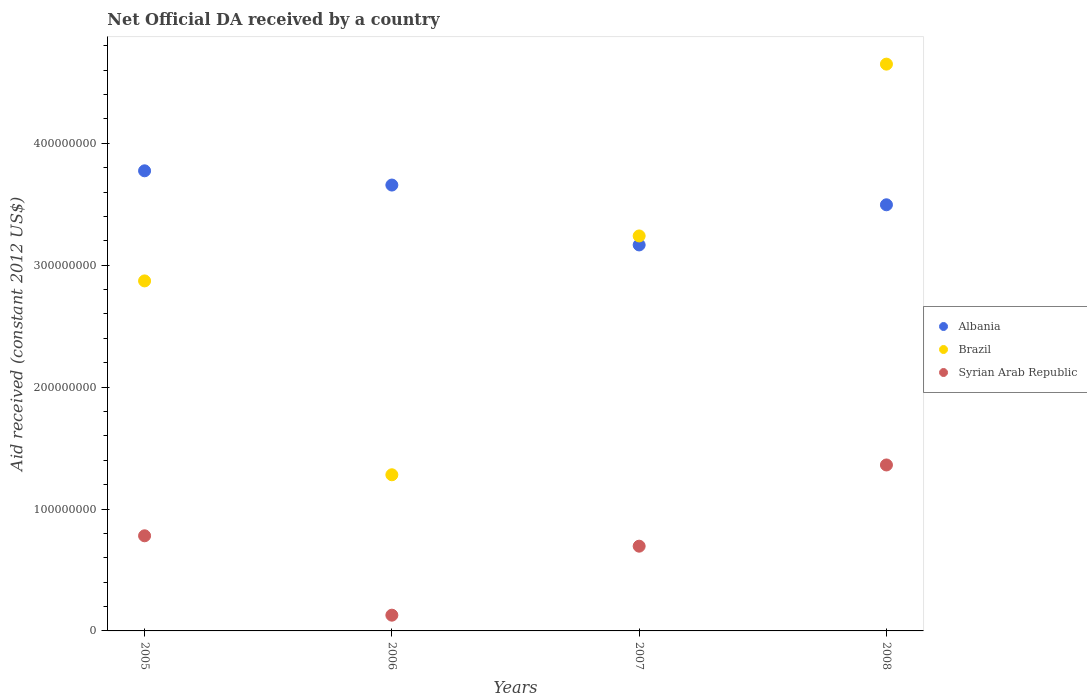How many different coloured dotlines are there?
Offer a very short reply. 3. Is the number of dotlines equal to the number of legend labels?
Make the answer very short. Yes. What is the net official development assistance aid received in Syrian Arab Republic in 2007?
Your response must be concise. 6.95e+07. Across all years, what is the maximum net official development assistance aid received in Syrian Arab Republic?
Keep it short and to the point. 1.36e+08. Across all years, what is the minimum net official development assistance aid received in Syrian Arab Republic?
Provide a short and direct response. 1.29e+07. In which year was the net official development assistance aid received in Syrian Arab Republic minimum?
Make the answer very short. 2006. What is the total net official development assistance aid received in Albania in the graph?
Provide a succinct answer. 1.41e+09. What is the difference between the net official development assistance aid received in Albania in 2005 and that in 2007?
Make the answer very short. 6.08e+07. What is the difference between the net official development assistance aid received in Syrian Arab Republic in 2006 and the net official development assistance aid received in Albania in 2007?
Keep it short and to the point. -3.04e+08. What is the average net official development assistance aid received in Brazil per year?
Provide a succinct answer. 3.01e+08. In the year 2005, what is the difference between the net official development assistance aid received in Albania and net official development assistance aid received in Syrian Arab Republic?
Provide a succinct answer. 2.99e+08. In how many years, is the net official development assistance aid received in Brazil greater than 420000000 US$?
Give a very brief answer. 1. What is the ratio of the net official development assistance aid received in Syrian Arab Republic in 2006 to that in 2008?
Keep it short and to the point. 0.09. Is the net official development assistance aid received in Brazil in 2005 less than that in 2007?
Your answer should be very brief. Yes. What is the difference between the highest and the second highest net official development assistance aid received in Brazil?
Offer a very short reply. 1.41e+08. What is the difference between the highest and the lowest net official development assistance aid received in Albania?
Offer a terse response. 6.08e+07. Is the sum of the net official development assistance aid received in Syrian Arab Republic in 2007 and 2008 greater than the maximum net official development assistance aid received in Brazil across all years?
Give a very brief answer. No. Is the net official development assistance aid received in Brazil strictly greater than the net official development assistance aid received in Albania over the years?
Ensure brevity in your answer.  No. Is the net official development assistance aid received in Albania strictly less than the net official development assistance aid received in Syrian Arab Republic over the years?
Keep it short and to the point. No. How many years are there in the graph?
Make the answer very short. 4. Where does the legend appear in the graph?
Provide a succinct answer. Center right. How many legend labels are there?
Your answer should be very brief. 3. How are the legend labels stacked?
Make the answer very short. Vertical. What is the title of the graph?
Ensure brevity in your answer.  Net Official DA received by a country. What is the label or title of the X-axis?
Keep it short and to the point. Years. What is the label or title of the Y-axis?
Keep it short and to the point. Aid received (constant 2012 US$). What is the Aid received (constant 2012 US$) of Albania in 2005?
Keep it short and to the point. 3.77e+08. What is the Aid received (constant 2012 US$) of Brazil in 2005?
Provide a succinct answer. 2.87e+08. What is the Aid received (constant 2012 US$) in Syrian Arab Republic in 2005?
Keep it short and to the point. 7.80e+07. What is the Aid received (constant 2012 US$) in Albania in 2006?
Your response must be concise. 3.66e+08. What is the Aid received (constant 2012 US$) of Brazil in 2006?
Offer a terse response. 1.28e+08. What is the Aid received (constant 2012 US$) in Syrian Arab Republic in 2006?
Your answer should be compact. 1.29e+07. What is the Aid received (constant 2012 US$) in Albania in 2007?
Provide a succinct answer. 3.17e+08. What is the Aid received (constant 2012 US$) of Brazil in 2007?
Offer a very short reply. 3.24e+08. What is the Aid received (constant 2012 US$) of Syrian Arab Republic in 2007?
Your response must be concise. 6.95e+07. What is the Aid received (constant 2012 US$) in Albania in 2008?
Your response must be concise. 3.50e+08. What is the Aid received (constant 2012 US$) of Brazil in 2008?
Offer a very short reply. 4.65e+08. What is the Aid received (constant 2012 US$) of Syrian Arab Republic in 2008?
Ensure brevity in your answer.  1.36e+08. Across all years, what is the maximum Aid received (constant 2012 US$) in Albania?
Your answer should be very brief. 3.77e+08. Across all years, what is the maximum Aid received (constant 2012 US$) of Brazil?
Your response must be concise. 4.65e+08. Across all years, what is the maximum Aid received (constant 2012 US$) of Syrian Arab Republic?
Provide a succinct answer. 1.36e+08. Across all years, what is the minimum Aid received (constant 2012 US$) of Albania?
Provide a short and direct response. 3.17e+08. Across all years, what is the minimum Aid received (constant 2012 US$) of Brazil?
Make the answer very short. 1.28e+08. Across all years, what is the minimum Aid received (constant 2012 US$) in Syrian Arab Republic?
Your answer should be very brief. 1.29e+07. What is the total Aid received (constant 2012 US$) in Albania in the graph?
Provide a short and direct response. 1.41e+09. What is the total Aid received (constant 2012 US$) in Brazil in the graph?
Provide a short and direct response. 1.20e+09. What is the total Aid received (constant 2012 US$) in Syrian Arab Republic in the graph?
Ensure brevity in your answer.  2.97e+08. What is the difference between the Aid received (constant 2012 US$) in Albania in 2005 and that in 2006?
Offer a terse response. 1.17e+07. What is the difference between the Aid received (constant 2012 US$) in Brazil in 2005 and that in 2006?
Offer a very short reply. 1.59e+08. What is the difference between the Aid received (constant 2012 US$) of Syrian Arab Republic in 2005 and that in 2006?
Your answer should be very brief. 6.51e+07. What is the difference between the Aid received (constant 2012 US$) in Albania in 2005 and that in 2007?
Make the answer very short. 6.08e+07. What is the difference between the Aid received (constant 2012 US$) of Brazil in 2005 and that in 2007?
Your answer should be compact. -3.69e+07. What is the difference between the Aid received (constant 2012 US$) in Syrian Arab Republic in 2005 and that in 2007?
Your answer should be very brief. 8.52e+06. What is the difference between the Aid received (constant 2012 US$) of Albania in 2005 and that in 2008?
Make the answer very short. 2.79e+07. What is the difference between the Aid received (constant 2012 US$) in Brazil in 2005 and that in 2008?
Your answer should be very brief. -1.78e+08. What is the difference between the Aid received (constant 2012 US$) of Syrian Arab Republic in 2005 and that in 2008?
Provide a succinct answer. -5.81e+07. What is the difference between the Aid received (constant 2012 US$) in Albania in 2006 and that in 2007?
Your response must be concise. 4.91e+07. What is the difference between the Aid received (constant 2012 US$) in Brazil in 2006 and that in 2007?
Give a very brief answer. -1.96e+08. What is the difference between the Aid received (constant 2012 US$) in Syrian Arab Republic in 2006 and that in 2007?
Your answer should be very brief. -5.66e+07. What is the difference between the Aid received (constant 2012 US$) in Albania in 2006 and that in 2008?
Give a very brief answer. 1.62e+07. What is the difference between the Aid received (constant 2012 US$) of Brazil in 2006 and that in 2008?
Provide a succinct answer. -3.37e+08. What is the difference between the Aid received (constant 2012 US$) of Syrian Arab Republic in 2006 and that in 2008?
Your answer should be compact. -1.23e+08. What is the difference between the Aid received (constant 2012 US$) of Albania in 2007 and that in 2008?
Provide a short and direct response. -3.29e+07. What is the difference between the Aid received (constant 2012 US$) in Brazil in 2007 and that in 2008?
Make the answer very short. -1.41e+08. What is the difference between the Aid received (constant 2012 US$) of Syrian Arab Republic in 2007 and that in 2008?
Keep it short and to the point. -6.66e+07. What is the difference between the Aid received (constant 2012 US$) in Albania in 2005 and the Aid received (constant 2012 US$) in Brazil in 2006?
Provide a succinct answer. 2.49e+08. What is the difference between the Aid received (constant 2012 US$) in Albania in 2005 and the Aid received (constant 2012 US$) in Syrian Arab Republic in 2006?
Keep it short and to the point. 3.65e+08. What is the difference between the Aid received (constant 2012 US$) in Brazil in 2005 and the Aid received (constant 2012 US$) in Syrian Arab Republic in 2006?
Your response must be concise. 2.74e+08. What is the difference between the Aid received (constant 2012 US$) of Albania in 2005 and the Aid received (constant 2012 US$) of Brazil in 2007?
Make the answer very short. 5.34e+07. What is the difference between the Aid received (constant 2012 US$) of Albania in 2005 and the Aid received (constant 2012 US$) of Syrian Arab Republic in 2007?
Your response must be concise. 3.08e+08. What is the difference between the Aid received (constant 2012 US$) of Brazil in 2005 and the Aid received (constant 2012 US$) of Syrian Arab Republic in 2007?
Give a very brief answer. 2.18e+08. What is the difference between the Aid received (constant 2012 US$) in Albania in 2005 and the Aid received (constant 2012 US$) in Brazil in 2008?
Give a very brief answer. -8.75e+07. What is the difference between the Aid received (constant 2012 US$) in Albania in 2005 and the Aid received (constant 2012 US$) in Syrian Arab Republic in 2008?
Offer a very short reply. 2.41e+08. What is the difference between the Aid received (constant 2012 US$) in Brazil in 2005 and the Aid received (constant 2012 US$) in Syrian Arab Republic in 2008?
Give a very brief answer. 1.51e+08. What is the difference between the Aid received (constant 2012 US$) of Albania in 2006 and the Aid received (constant 2012 US$) of Brazil in 2007?
Provide a succinct answer. 4.18e+07. What is the difference between the Aid received (constant 2012 US$) in Albania in 2006 and the Aid received (constant 2012 US$) in Syrian Arab Republic in 2007?
Keep it short and to the point. 2.96e+08. What is the difference between the Aid received (constant 2012 US$) of Brazil in 2006 and the Aid received (constant 2012 US$) of Syrian Arab Republic in 2007?
Provide a succinct answer. 5.86e+07. What is the difference between the Aid received (constant 2012 US$) of Albania in 2006 and the Aid received (constant 2012 US$) of Brazil in 2008?
Offer a very short reply. -9.92e+07. What is the difference between the Aid received (constant 2012 US$) of Albania in 2006 and the Aid received (constant 2012 US$) of Syrian Arab Republic in 2008?
Your answer should be compact. 2.30e+08. What is the difference between the Aid received (constant 2012 US$) of Brazil in 2006 and the Aid received (constant 2012 US$) of Syrian Arab Republic in 2008?
Offer a terse response. -8.05e+06. What is the difference between the Aid received (constant 2012 US$) in Albania in 2007 and the Aid received (constant 2012 US$) in Brazil in 2008?
Provide a succinct answer. -1.48e+08. What is the difference between the Aid received (constant 2012 US$) of Albania in 2007 and the Aid received (constant 2012 US$) of Syrian Arab Republic in 2008?
Your answer should be very brief. 1.80e+08. What is the difference between the Aid received (constant 2012 US$) in Brazil in 2007 and the Aid received (constant 2012 US$) in Syrian Arab Republic in 2008?
Ensure brevity in your answer.  1.88e+08. What is the average Aid received (constant 2012 US$) of Albania per year?
Your answer should be compact. 3.52e+08. What is the average Aid received (constant 2012 US$) in Brazil per year?
Keep it short and to the point. 3.01e+08. What is the average Aid received (constant 2012 US$) in Syrian Arab Republic per year?
Keep it short and to the point. 7.42e+07. In the year 2005, what is the difference between the Aid received (constant 2012 US$) in Albania and Aid received (constant 2012 US$) in Brazil?
Provide a short and direct response. 9.03e+07. In the year 2005, what is the difference between the Aid received (constant 2012 US$) in Albania and Aid received (constant 2012 US$) in Syrian Arab Republic?
Provide a short and direct response. 2.99e+08. In the year 2005, what is the difference between the Aid received (constant 2012 US$) in Brazil and Aid received (constant 2012 US$) in Syrian Arab Republic?
Your answer should be very brief. 2.09e+08. In the year 2006, what is the difference between the Aid received (constant 2012 US$) of Albania and Aid received (constant 2012 US$) of Brazil?
Offer a very short reply. 2.38e+08. In the year 2006, what is the difference between the Aid received (constant 2012 US$) in Albania and Aid received (constant 2012 US$) in Syrian Arab Republic?
Your response must be concise. 3.53e+08. In the year 2006, what is the difference between the Aid received (constant 2012 US$) in Brazil and Aid received (constant 2012 US$) in Syrian Arab Republic?
Provide a short and direct response. 1.15e+08. In the year 2007, what is the difference between the Aid received (constant 2012 US$) of Albania and Aid received (constant 2012 US$) of Brazil?
Offer a terse response. -7.38e+06. In the year 2007, what is the difference between the Aid received (constant 2012 US$) of Albania and Aid received (constant 2012 US$) of Syrian Arab Republic?
Offer a terse response. 2.47e+08. In the year 2007, what is the difference between the Aid received (constant 2012 US$) of Brazil and Aid received (constant 2012 US$) of Syrian Arab Republic?
Make the answer very short. 2.55e+08. In the year 2008, what is the difference between the Aid received (constant 2012 US$) in Albania and Aid received (constant 2012 US$) in Brazil?
Make the answer very short. -1.15e+08. In the year 2008, what is the difference between the Aid received (constant 2012 US$) of Albania and Aid received (constant 2012 US$) of Syrian Arab Republic?
Give a very brief answer. 2.13e+08. In the year 2008, what is the difference between the Aid received (constant 2012 US$) in Brazil and Aid received (constant 2012 US$) in Syrian Arab Republic?
Your answer should be compact. 3.29e+08. What is the ratio of the Aid received (constant 2012 US$) in Albania in 2005 to that in 2006?
Make the answer very short. 1.03. What is the ratio of the Aid received (constant 2012 US$) of Brazil in 2005 to that in 2006?
Ensure brevity in your answer.  2.24. What is the ratio of the Aid received (constant 2012 US$) in Syrian Arab Republic in 2005 to that in 2006?
Your response must be concise. 6.04. What is the ratio of the Aid received (constant 2012 US$) of Albania in 2005 to that in 2007?
Your answer should be very brief. 1.19. What is the ratio of the Aid received (constant 2012 US$) of Brazil in 2005 to that in 2007?
Provide a succinct answer. 0.89. What is the ratio of the Aid received (constant 2012 US$) in Syrian Arab Republic in 2005 to that in 2007?
Give a very brief answer. 1.12. What is the ratio of the Aid received (constant 2012 US$) of Albania in 2005 to that in 2008?
Your answer should be very brief. 1.08. What is the ratio of the Aid received (constant 2012 US$) of Brazil in 2005 to that in 2008?
Your response must be concise. 0.62. What is the ratio of the Aid received (constant 2012 US$) of Syrian Arab Republic in 2005 to that in 2008?
Make the answer very short. 0.57. What is the ratio of the Aid received (constant 2012 US$) in Albania in 2006 to that in 2007?
Make the answer very short. 1.16. What is the ratio of the Aid received (constant 2012 US$) in Brazil in 2006 to that in 2007?
Your response must be concise. 0.4. What is the ratio of the Aid received (constant 2012 US$) of Syrian Arab Republic in 2006 to that in 2007?
Ensure brevity in your answer.  0.19. What is the ratio of the Aid received (constant 2012 US$) of Albania in 2006 to that in 2008?
Ensure brevity in your answer.  1.05. What is the ratio of the Aid received (constant 2012 US$) in Brazil in 2006 to that in 2008?
Give a very brief answer. 0.28. What is the ratio of the Aid received (constant 2012 US$) in Syrian Arab Republic in 2006 to that in 2008?
Your response must be concise. 0.09. What is the ratio of the Aid received (constant 2012 US$) of Albania in 2007 to that in 2008?
Offer a terse response. 0.91. What is the ratio of the Aid received (constant 2012 US$) of Brazil in 2007 to that in 2008?
Provide a short and direct response. 0.7. What is the ratio of the Aid received (constant 2012 US$) of Syrian Arab Republic in 2007 to that in 2008?
Provide a short and direct response. 0.51. What is the difference between the highest and the second highest Aid received (constant 2012 US$) in Albania?
Make the answer very short. 1.17e+07. What is the difference between the highest and the second highest Aid received (constant 2012 US$) in Brazil?
Offer a terse response. 1.41e+08. What is the difference between the highest and the second highest Aid received (constant 2012 US$) of Syrian Arab Republic?
Offer a terse response. 5.81e+07. What is the difference between the highest and the lowest Aid received (constant 2012 US$) of Albania?
Your response must be concise. 6.08e+07. What is the difference between the highest and the lowest Aid received (constant 2012 US$) in Brazil?
Your answer should be very brief. 3.37e+08. What is the difference between the highest and the lowest Aid received (constant 2012 US$) in Syrian Arab Republic?
Make the answer very short. 1.23e+08. 